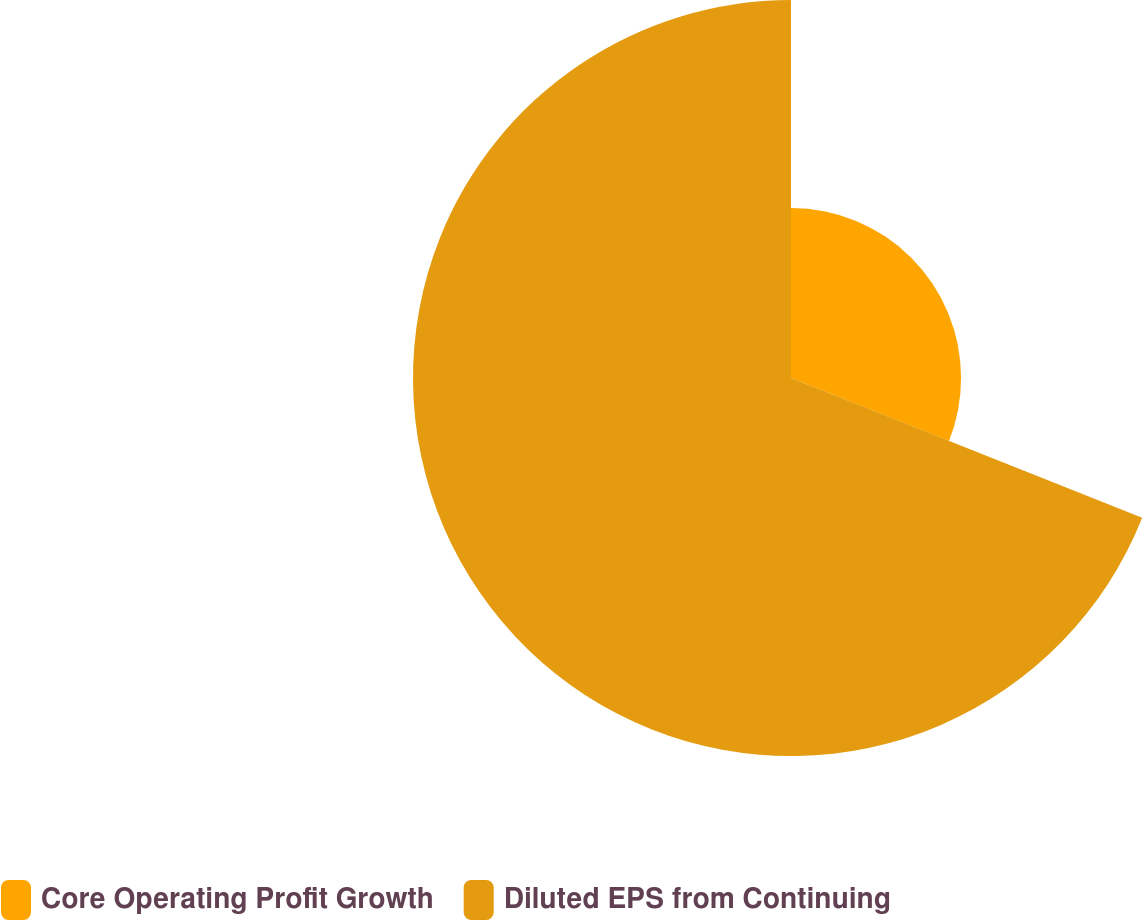<chart> <loc_0><loc_0><loc_500><loc_500><pie_chart><fcel>Core Operating Profit Growth<fcel>Diluted EPS from Continuing<nl><fcel>31.03%<fcel>68.97%<nl></chart> 